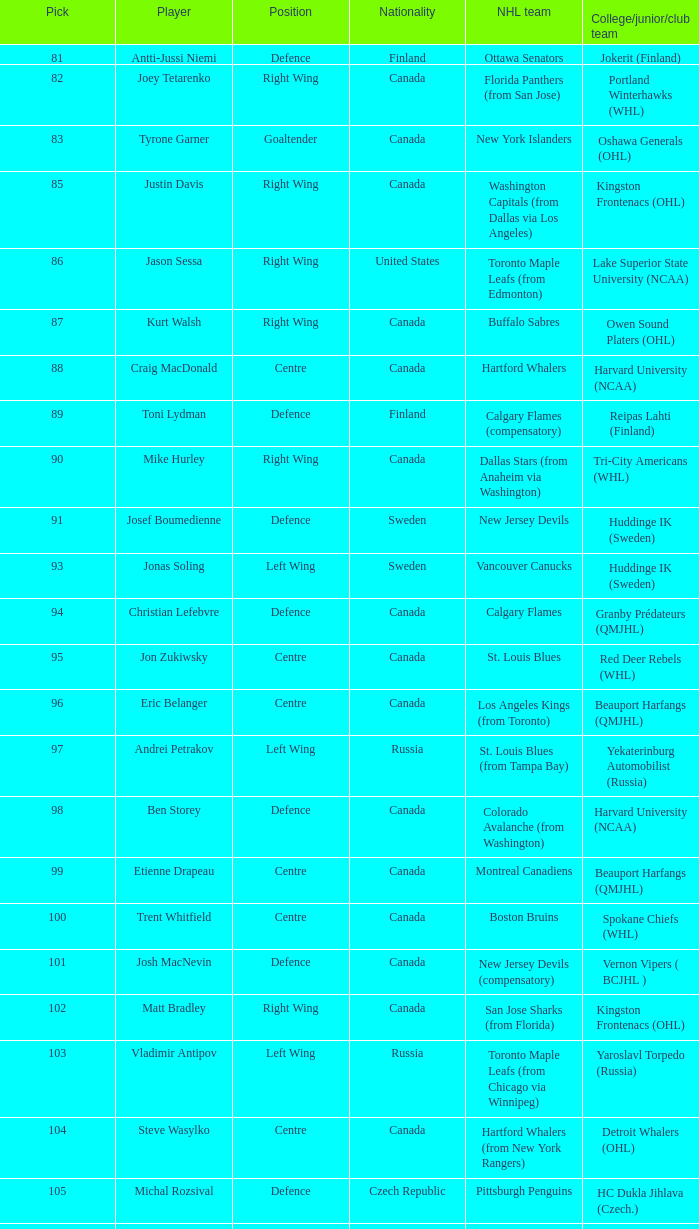What is the country of origin for christian lefebvre? Canada. 